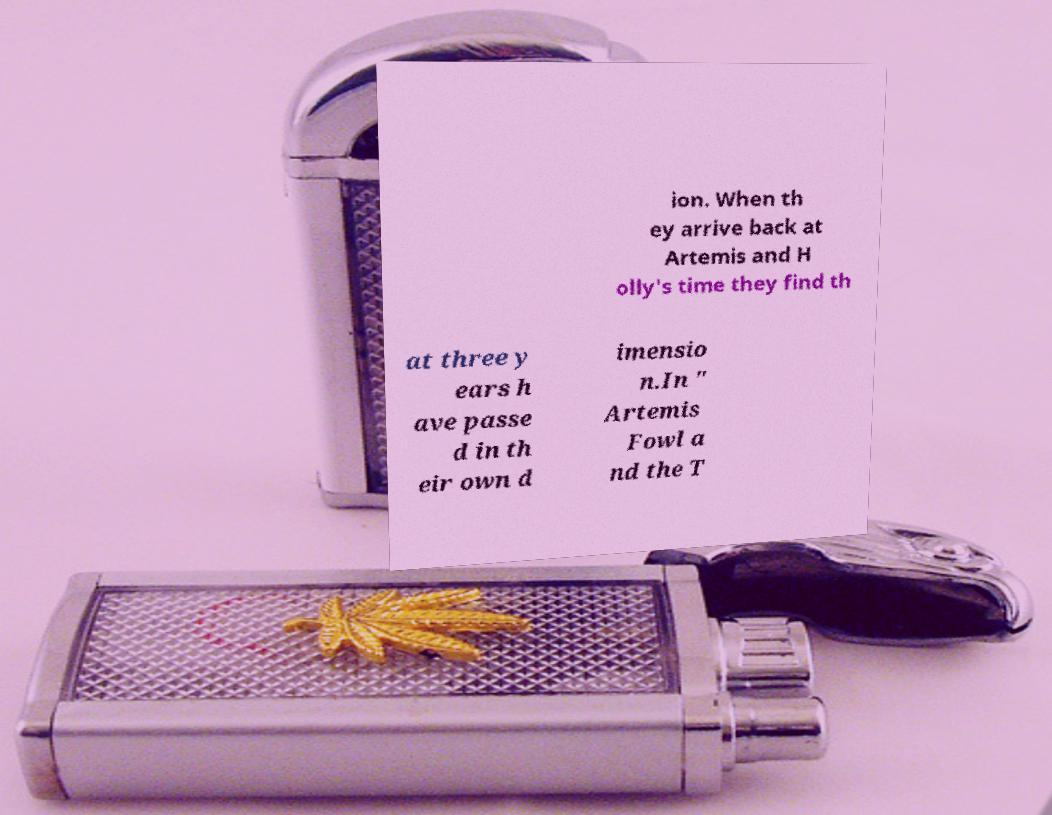What messages or text are displayed in this image? I need them in a readable, typed format. ion. When th ey arrive back at Artemis and H olly's time they find th at three y ears h ave passe d in th eir own d imensio n.In " Artemis Fowl a nd the T 